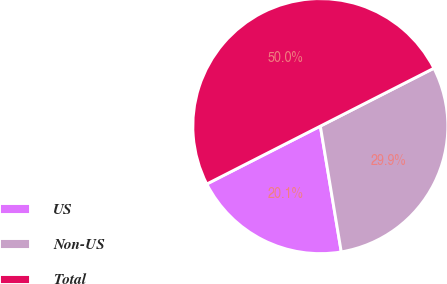Convert chart to OTSL. <chart><loc_0><loc_0><loc_500><loc_500><pie_chart><fcel>US<fcel>Non-US<fcel>Total<nl><fcel>20.12%<fcel>29.88%<fcel>50.0%<nl></chart> 